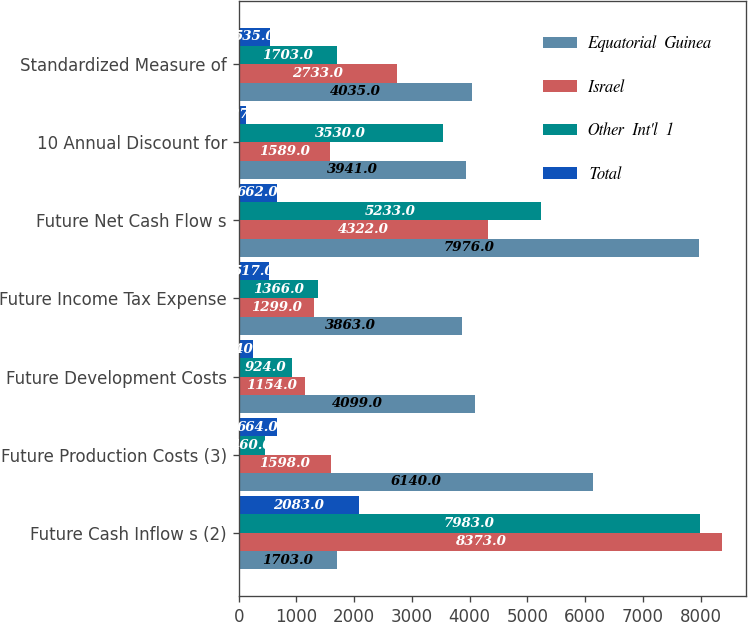Convert chart to OTSL. <chart><loc_0><loc_0><loc_500><loc_500><stacked_bar_chart><ecel><fcel>Future Cash Inflow s (2)<fcel>Future Production Costs (3)<fcel>Future Development Costs<fcel>Future Income Tax Expense<fcel>Future Net Cash Flow s<fcel>10 Annual Discount for<fcel>Standardized Measure of<nl><fcel>Equatorial  Guinea<fcel>1703<fcel>6140<fcel>4099<fcel>3863<fcel>7976<fcel>3941<fcel>4035<nl><fcel>Israel<fcel>8373<fcel>1598<fcel>1154<fcel>1299<fcel>4322<fcel>1589<fcel>2733<nl><fcel>Other  Int'l  1<fcel>7983<fcel>460<fcel>924<fcel>1366<fcel>5233<fcel>3530<fcel>1703<nl><fcel>Total<fcel>2083<fcel>664<fcel>240<fcel>517<fcel>662<fcel>127<fcel>535<nl></chart> 